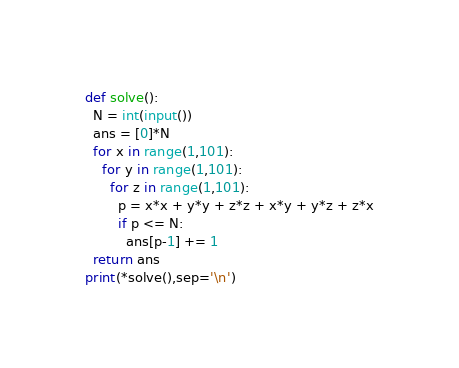Convert code to text. <code><loc_0><loc_0><loc_500><loc_500><_Cython_>def solve():
  N = int(input())
  ans = [0]*N
  for x in range(1,101):
    for y in range(1,101):
      for z in range(1,101):
        p = x*x + y*y + z*z + x*y + y*z + z*x
        if p <= N:
          ans[p-1] += 1
  return ans
print(*solve(),sep='\n')
</code> 